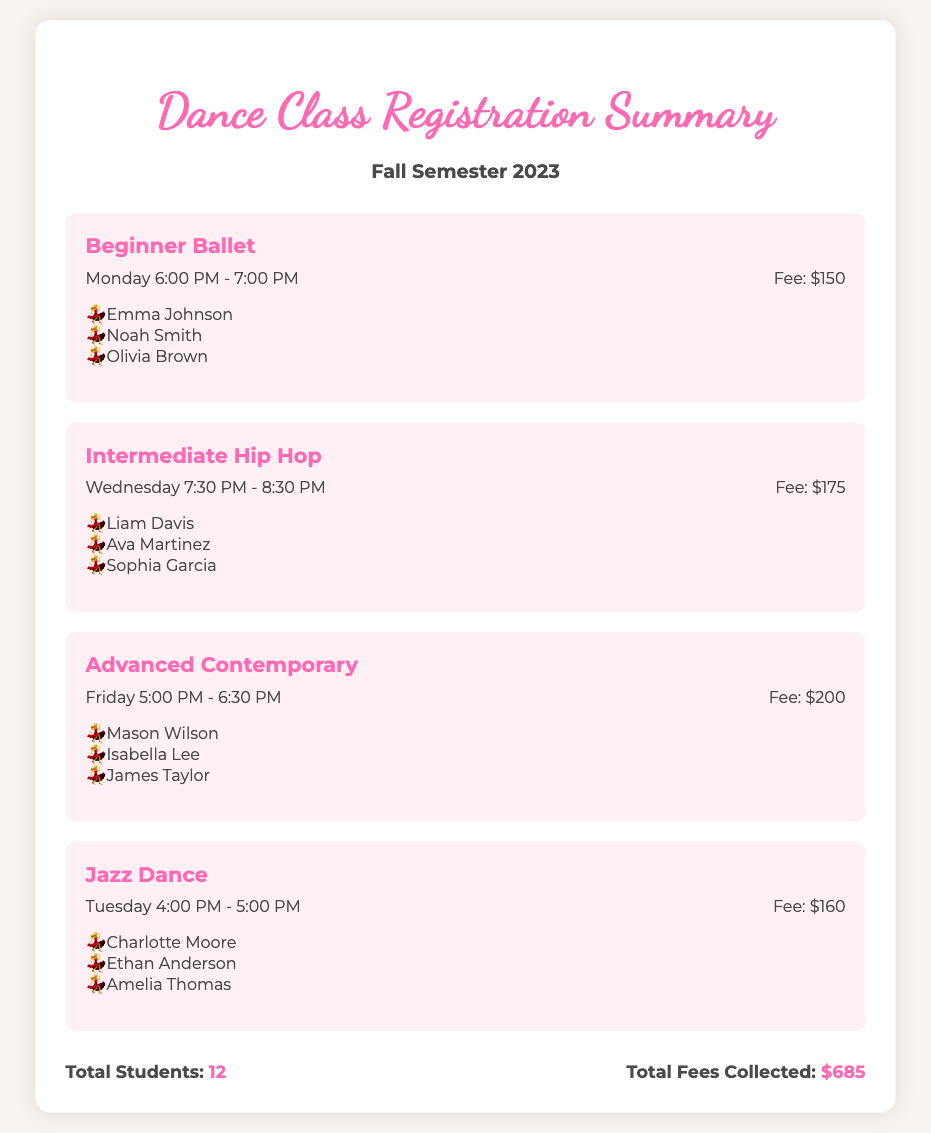What is the name of the class held on Monday? The class held on Monday is Beginner Ballet as stated in the document.
Answer: Beginner Ballet How many students are registered for Intermediate Hip Hop? The document lists three students registered for Intermediate Hip Hop.
Answer: 3 What is the fee for Advanced Contemporary? The fee for Advanced Contemporary is displayed in the class details.
Answer: $200 Which day and time is Jazz Dance scheduled? The document specifies that Jazz Dance is scheduled for Tuesday at 4:00 PM - 5:00 PM.
Answer: Tuesday 4:00 PM - 5:00 PM What is the total number of students registered? The document provides a summary showing the total number of students registered for all classes.
Answer: 12 What is the total fees collected for the semester? The summary section of the document indicates the total fees collected.
Answer: $685 Which class has the highest fee? By comparing the fees of all classes listed, Advanced Contemporary has the highest fee.
Answer: Advanced Contemporary Who is the last student listed under Beginner Ballet? The document lists the students enrolled in Beginner Ballet, with the last one being Olivia Brown.
Answer: Olivia Brown What class is taught on Wednesday? The class scheduled for Wednesday is mentioned in the document as Intermediate Hip Hop.
Answer: Intermediate Hip Hop 